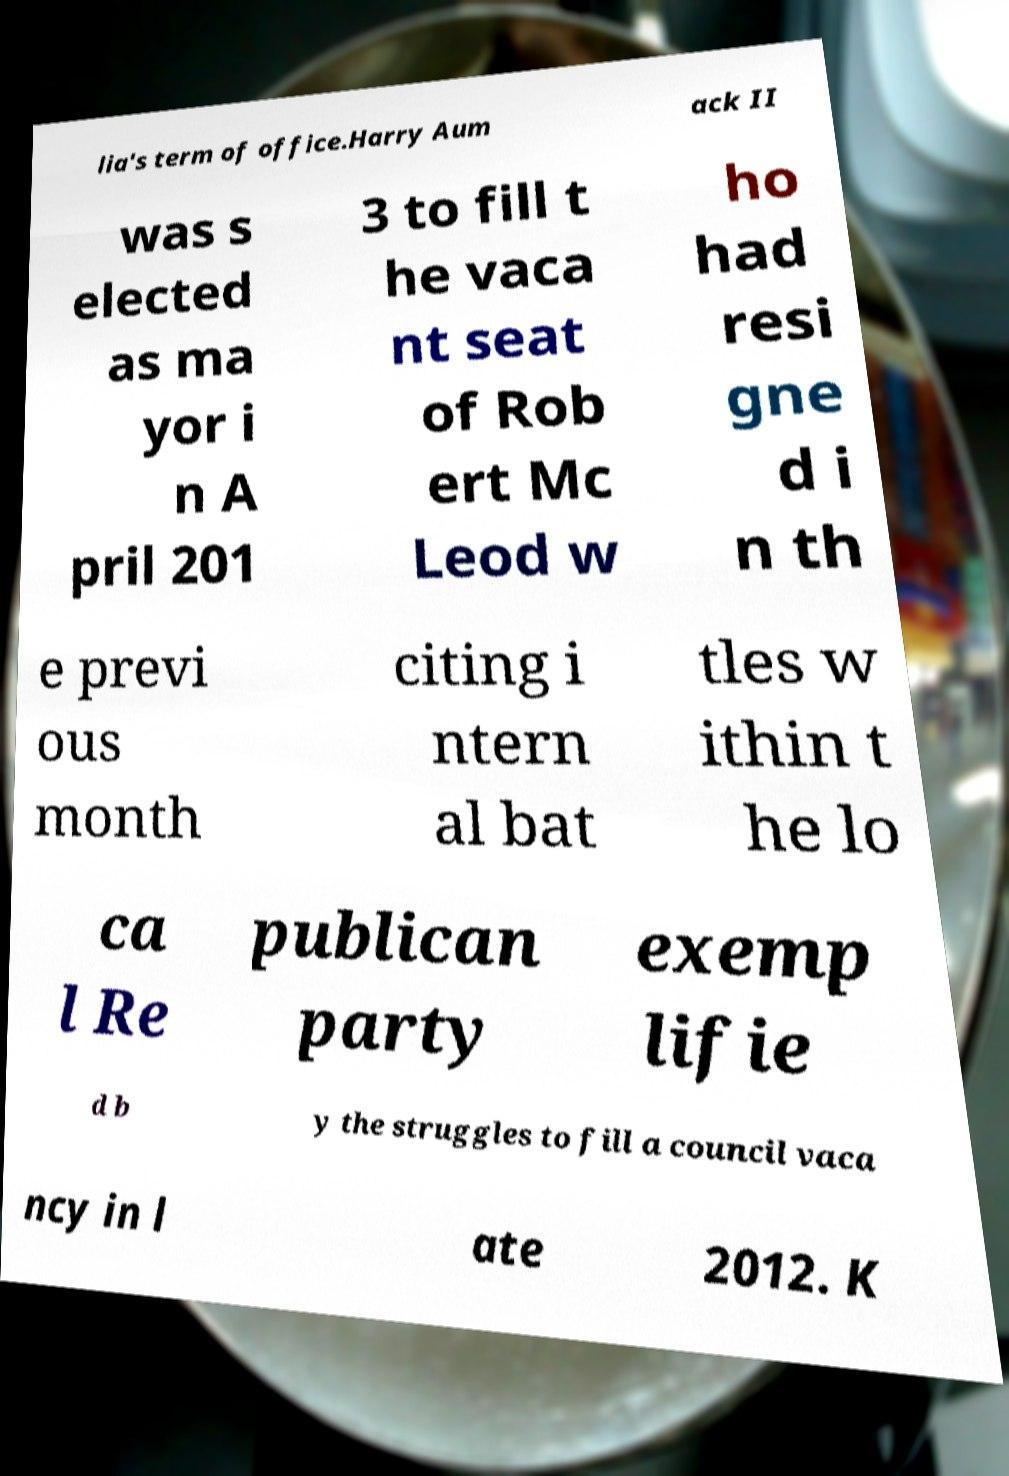Could you assist in decoding the text presented in this image and type it out clearly? lia's term of office.Harry Aum ack II was s elected as ma yor i n A pril 201 3 to fill t he vaca nt seat of Rob ert Mc Leod w ho had resi gne d i n th e previ ous month citing i ntern al bat tles w ithin t he lo ca l Re publican party exemp lifie d b y the struggles to fill a council vaca ncy in l ate 2012. K 